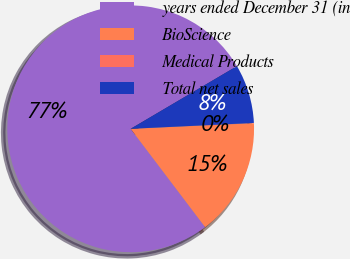Convert chart to OTSL. <chart><loc_0><loc_0><loc_500><loc_500><pie_chart><fcel>years ended December 31 (in<fcel>BioScience<fcel>Medical Products<fcel>Total net sales<nl><fcel>76.84%<fcel>15.4%<fcel>0.04%<fcel>7.72%<nl></chart> 